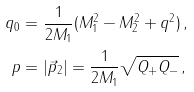<formula> <loc_0><loc_0><loc_500><loc_500>q _ { 0 } & = \frac { 1 } { 2 M _ { 1 } } ( M _ { 1 } ^ { 2 } - M _ { 2 } ^ { 2 } + q ^ { 2 } ) \, , \\ p & = | \vec { p } _ { 2 } | = \frac { 1 } { 2 M _ { 1 } } \sqrt { Q _ { + } Q _ { - } } \, ,</formula> 